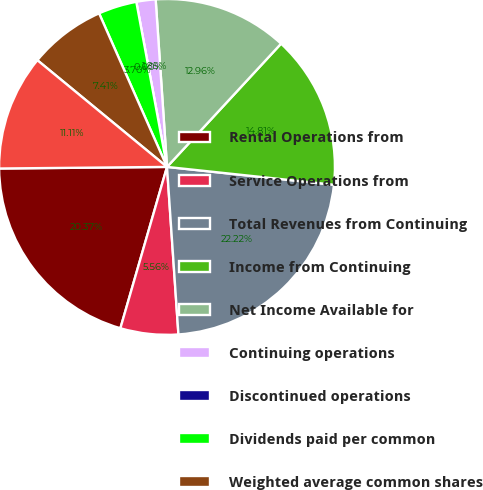Convert chart. <chart><loc_0><loc_0><loc_500><loc_500><pie_chart><fcel>Rental Operations from<fcel>Service Operations from<fcel>Total Revenues from Continuing<fcel>Income from Continuing<fcel>Net Income Available for<fcel>Continuing operations<fcel>Discontinued operations<fcel>Dividends paid per common<fcel>Weighted average common shares<fcel>Weighted average common and<nl><fcel>20.37%<fcel>5.56%<fcel>22.22%<fcel>14.81%<fcel>12.96%<fcel>1.85%<fcel>0.0%<fcel>3.7%<fcel>7.41%<fcel>11.11%<nl></chart> 